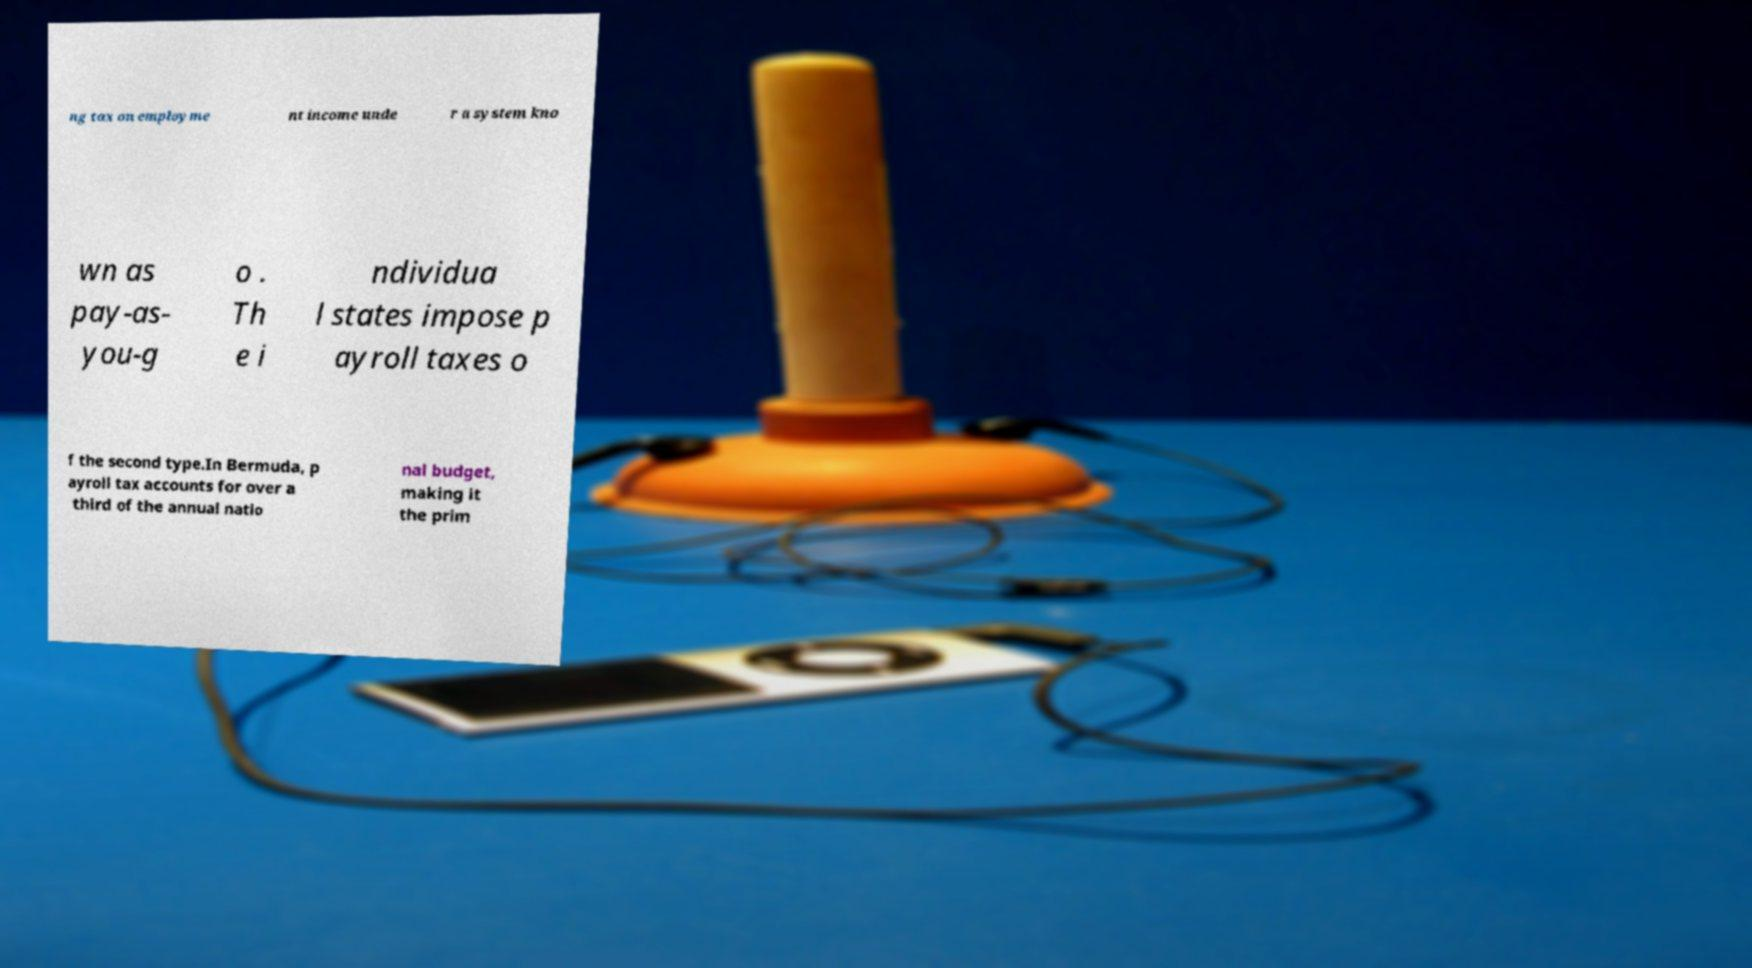Could you assist in decoding the text presented in this image and type it out clearly? ng tax on employme nt income unde r a system kno wn as pay-as- you-g o . Th e i ndividua l states impose p ayroll taxes o f the second type.In Bermuda, p ayroll tax accounts for over a third of the annual natio nal budget, making it the prim 